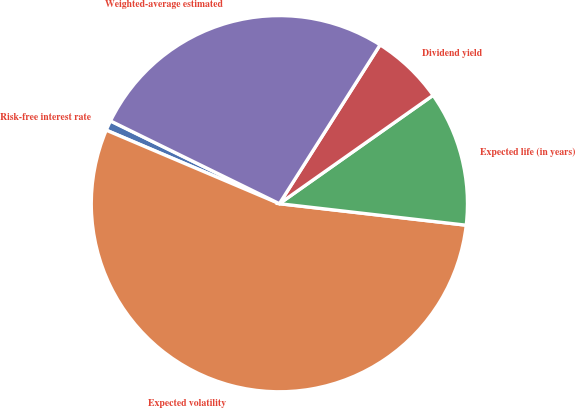<chart> <loc_0><loc_0><loc_500><loc_500><pie_chart><fcel>Risk-free interest rate<fcel>Expected volatility<fcel>Expected life (in years)<fcel>Dividend yield<fcel>Weighted-average estimated<nl><fcel>0.86%<fcel>54.56%<fcel>11.6%<fcel>6.23%<fcel>26.74%<nl></chart> 